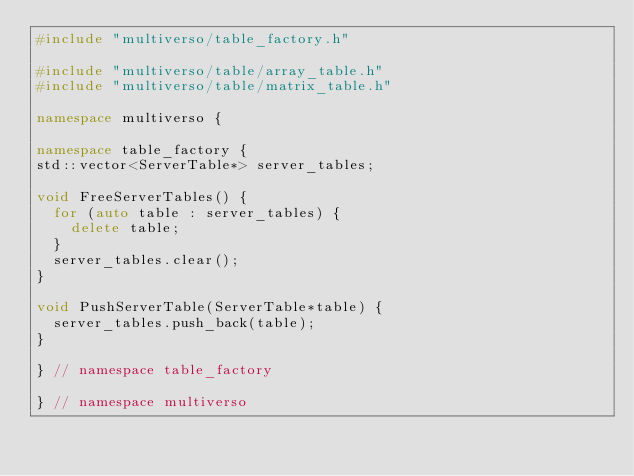<code> <loc_0><loc_0><loc_500><loc_500><_C++_>#include "multiverso/table_factory.h"

#include "multiverso/table/array_table.h"
#include "multiverso/table/matrix_table.h"

namespace multiverso {

namespace table_factory {
std::vector<ServerTable*> server_tables;

void FreeServerTables() {
  for (auto table : server_tables) {
    delete table;
  }
  server_tables.clear();
}

void PushServerTable(ServerTable*table) {
  server_tables.push_back(table);
}

} // namespace table_factory

} // namespace multiverso</code> 